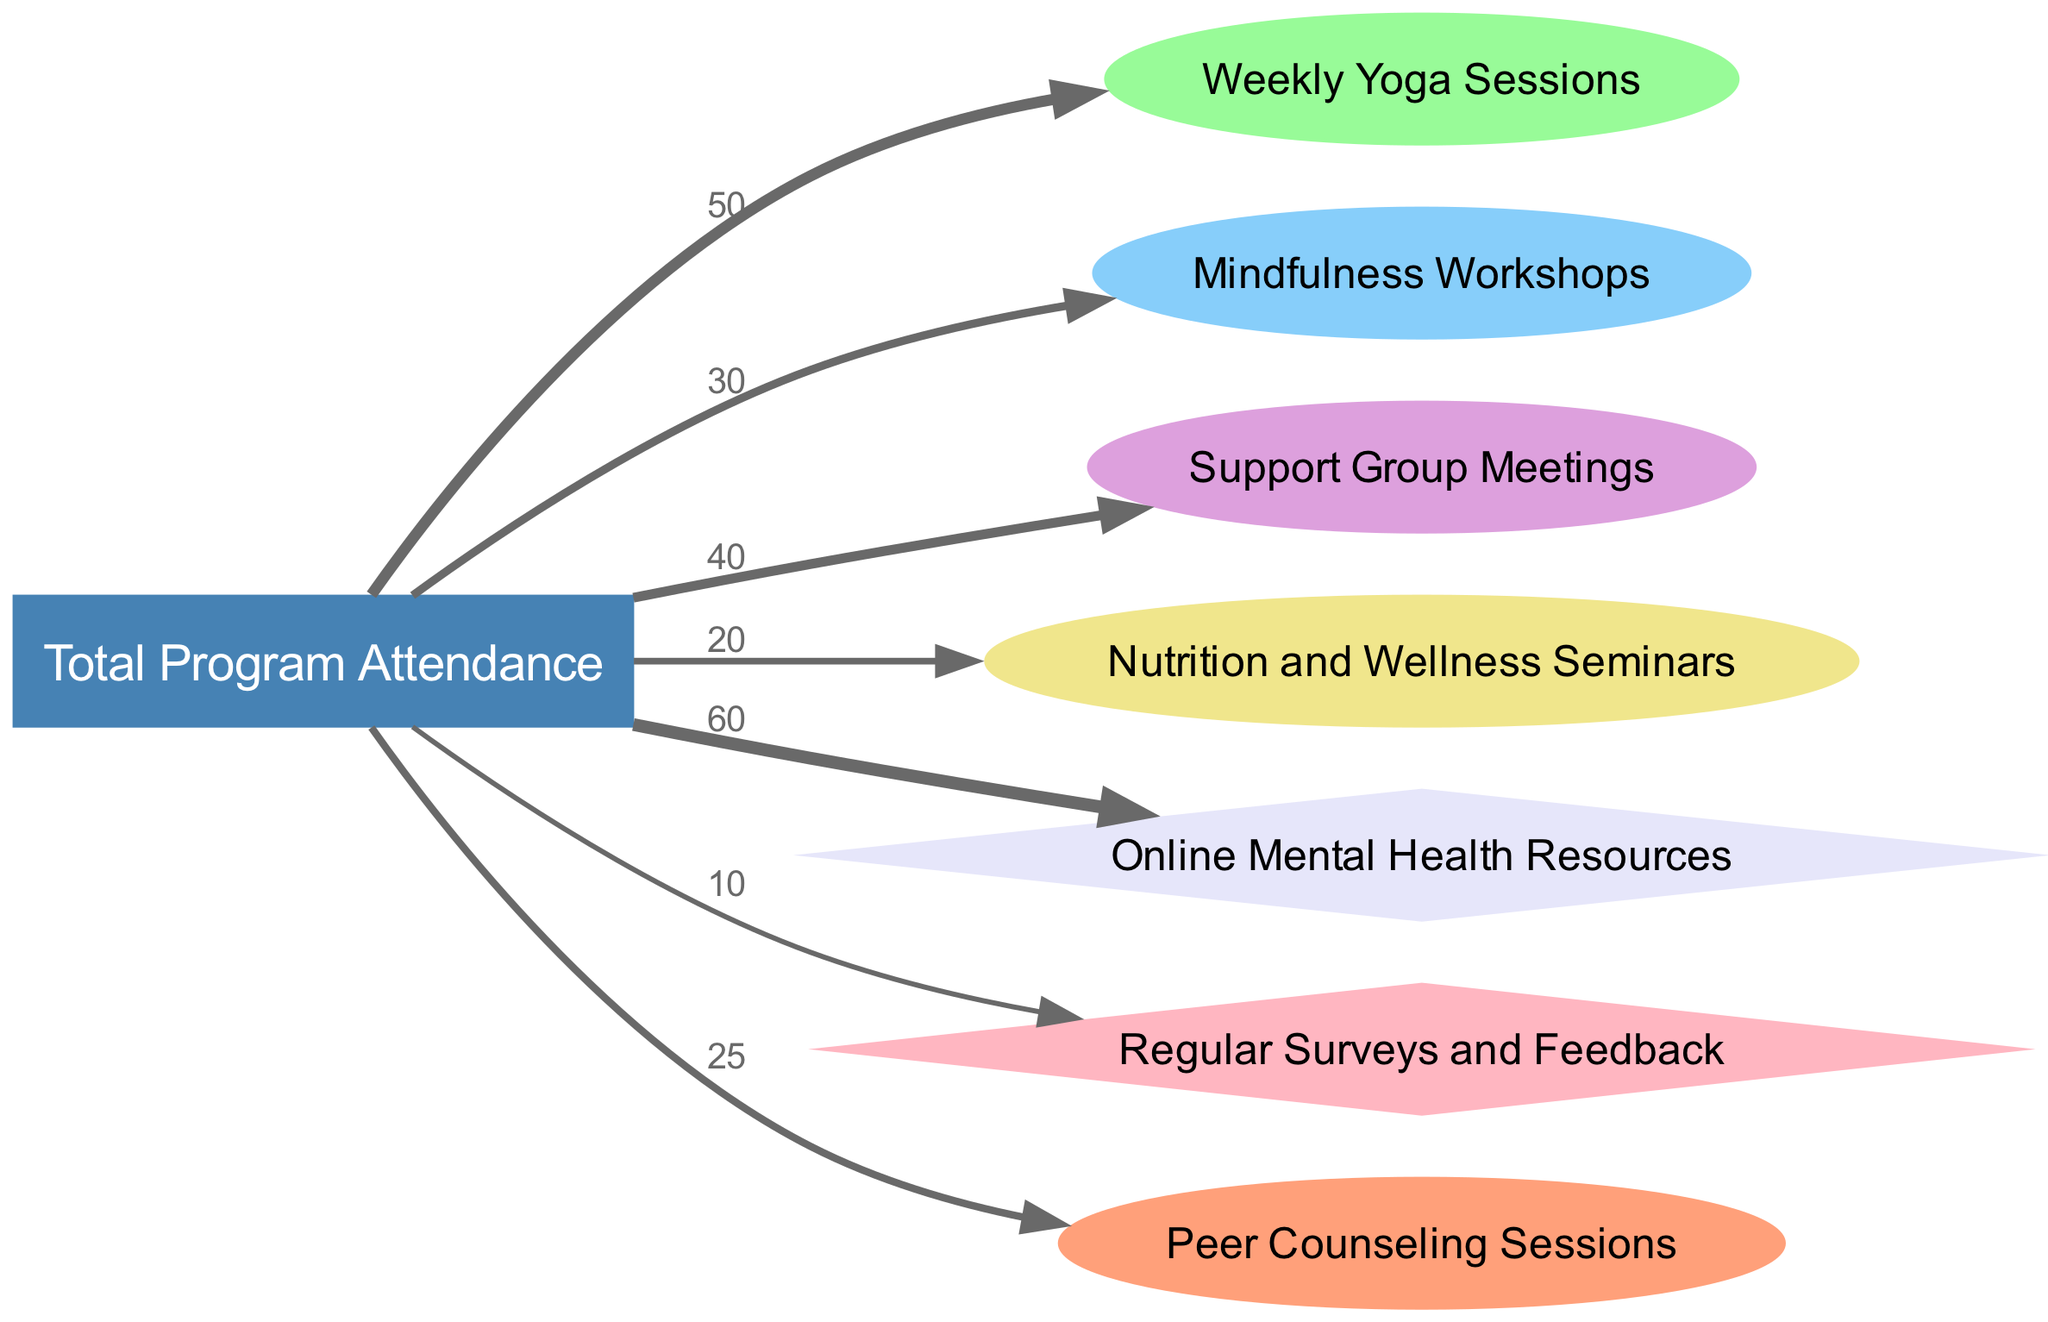What is the total value of program attendance? The diagram presents a total of all program attendance values linked to the "Total Program Attendance" node. By summing all the values from the links, we find: 50 + 30 + 40 + 20 + 60 + 10 + 25 = 255.
Answer: 255 How many different programs are represented in the diagram? The diagram lists the various programs that receive attendance values. There are six distinct programs shown: Weekly Yoga Sessions, Mindfulness Workshops, Support Group Meetings, Nutrition and Wellness Seminars, Peer Counseling Sessions, and Online Mental Health Resources.
Answer: 6 Which program had the highest attendance? By examining the values linked to each program node, we see that "Online Mental Health Resources" has the highest value at 60, compared to others.
Answer: Online Mental Health Resources What value corresponds to the Support Group Meetings? The link from "Total Program Attendance" to "Support Group Meetings" shows a value of 40. This indicates the number of attendees for that program.
Answer: 40 What is the relationship between Nutrition and Wellness Seminars and Total Program Attendance? The "Nutrition and Wellness Seminars" node is connected to the "Total Program Attendance" node with a link that has a value of 20, indicating the attendance for that program as part of the total.
Answer: 20 Which resource had the least attendance? Reviewing the resource connections, "Regular Surveys and Feedback" is linked with a value of 10, which is the lowest among all resources.
Answer: Regular Surveys and Feedback What percentage of total attendance was for Weekly Yoga Sessions? The link to "Weekly Yoga Sessions" shows a value of 50. To find the percentage: (50/255) * 100 = 19.61%.
Answer: 19.61% Which program has the lowest attendance? Comparing the values of each program, "Nutrition and Wellness Seminars" has the lowest attendance value of 20.
Answer: Nutrition and Wellness Seminars How many connections (links) flow from the Total Program Attendance? The diagram indicates multiple connections. Specifically, there are seven distinct links originating from "Total Program Attendance."
Answer: 7 